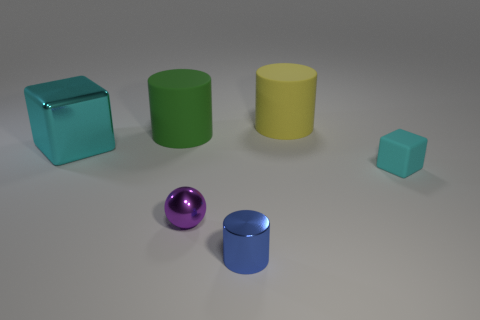Which object stands out the most to you and why? The reflective purple sphere stands out the most. Its material is highly reflective, giving it a shiny appearance that contrasts with the matte surface of the other objects. It also seems to be the only spherical object among other geometric shapes, which draws the eye to its uniqueness. How might the lighting affect our perception of the materials? The lighting plays a key role in our perception of materials. It highlights the reflective qualities of shiny objects like the purple sphere, while also revealing the texture of matte surfaces, such as on the yellow cylinder. Differences in shadow and brightness help our eyes discern the varying materials and understand their potential tactile feel. 